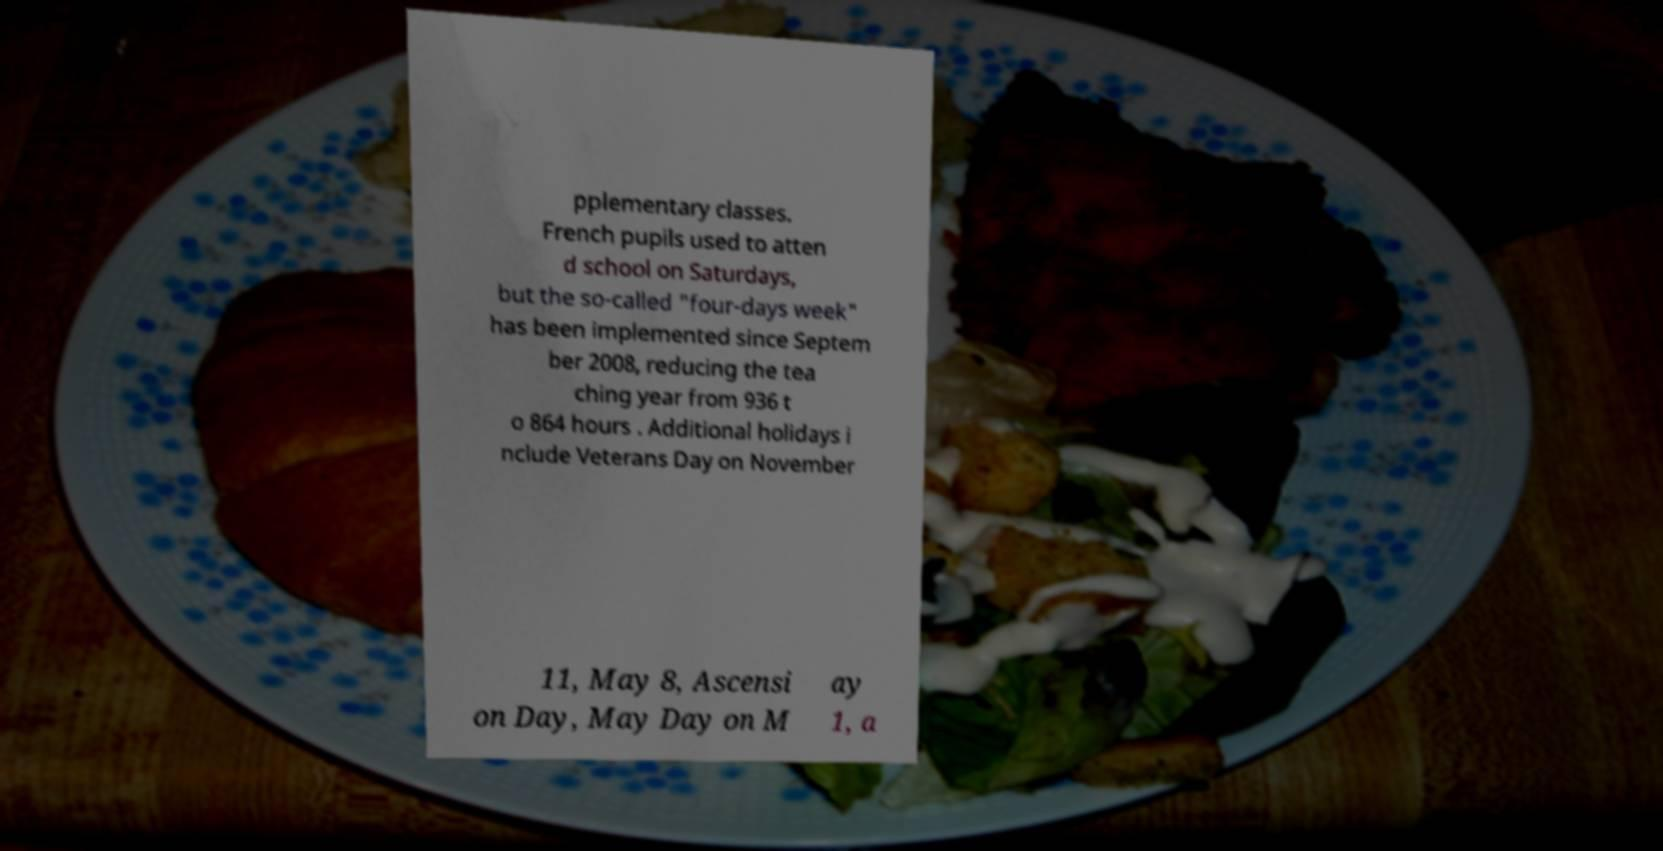Can you accurately transcribe the text from the provided image for me? pplementary classes. French pupils used to atten d school on Saturdays, but the so-called "four-days week" has been implemented since Septem ber 2008, reducing the tea ching year from 936 t o 864 hours . Additional holidays i nclude Veterans Day on November 11, May 8, Ascensi on Day, May Day on M ay 1, a 